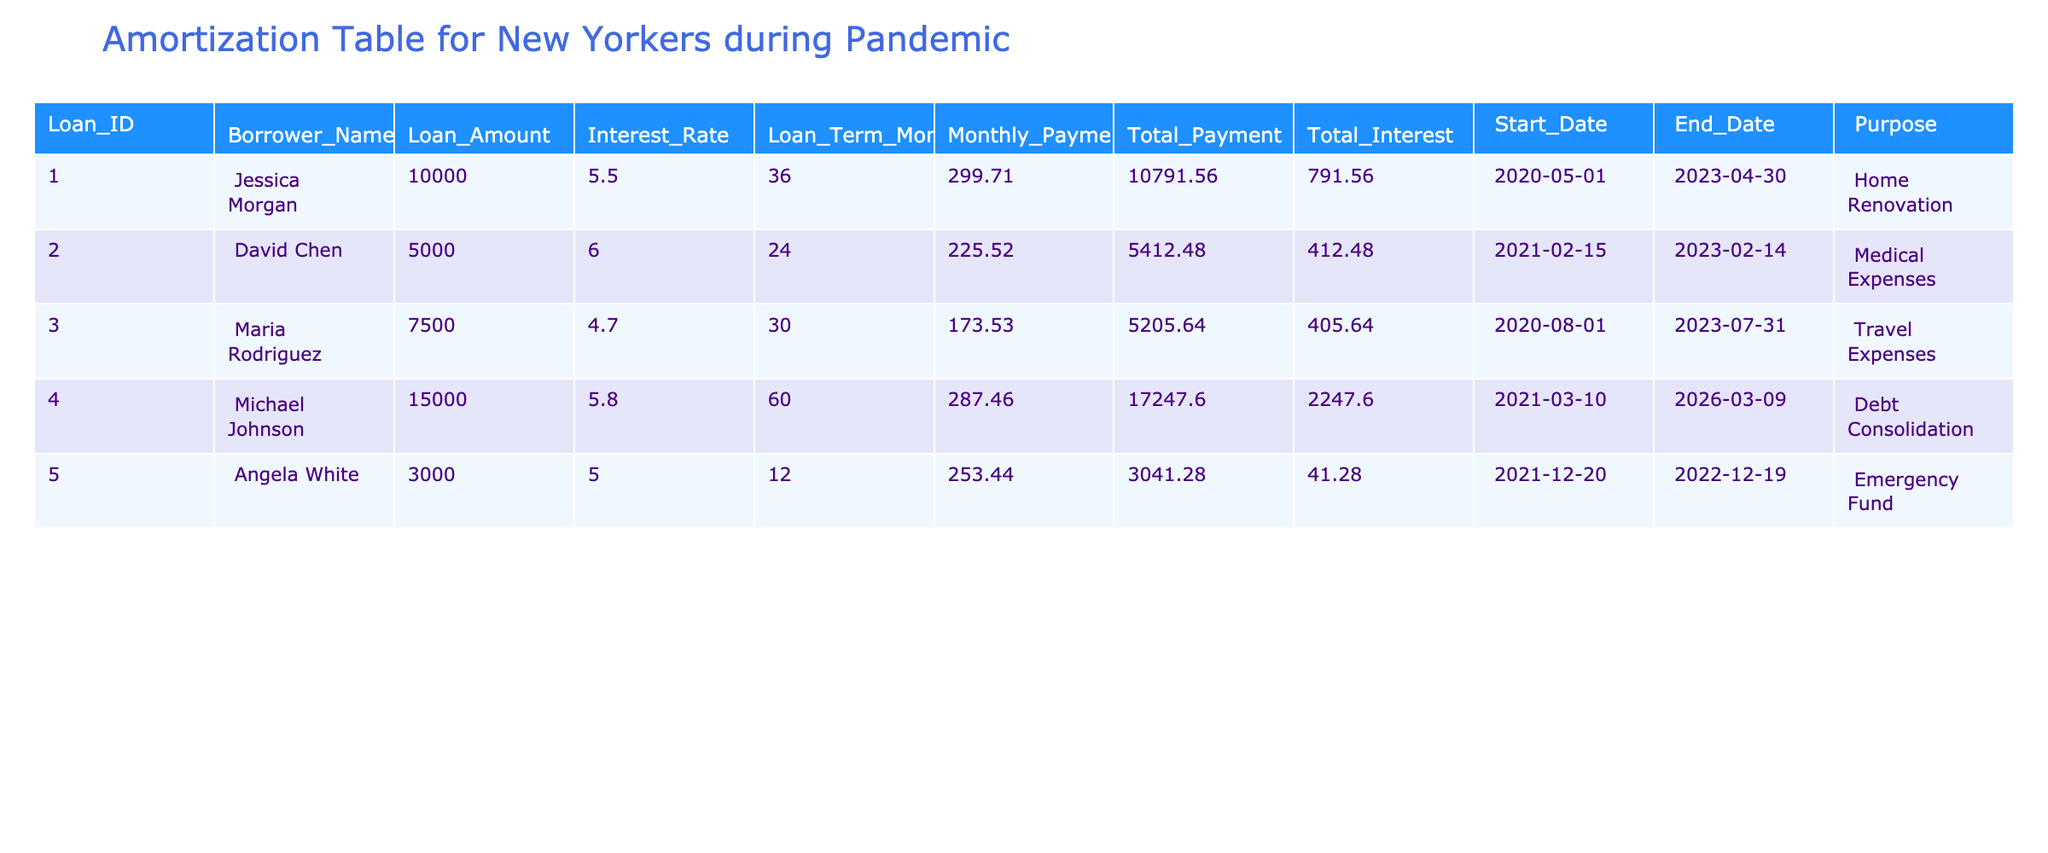What is the total loan amount of all borrowers listed in the table? To find the total loan amount, we add up the Loan Amount column: 10000 + 5000 + 7500 + 15000 + 3000 = 40500.
Answer: 40500 How much total interest did David Chen pay over the course of his loan? The Total Interest column shows 412.48 for David Chen.
Answer: 412.48 Which loan has the highest monthly payment, and what is that amount? Looking at the Monthly Payment column, Michael Johnson has the highest payment of 287.46.
Answer: 287.46 Is there a loan taken out for travel expenses? Yes, Maria Rodriguez took out a loan for travel expenses as listed in the Purpose column.
Answer: Yes What is the average interest rate of all the loans in the table? To find the average interest rate, we sum the Interest Rates (5.5 + 6 + 4.7 + 5.8 + 5.0 = 27) and divide by the number of loans (5): 27 / 5 = 5.4.
Answer: 5.4 Which borrower has the longest loan term, and how many months is it? The longest loan term is for Michael Johnson with a term of 60 months, as we see in the Loan Term Months column.
Answer: 60 months How much did Angela White pay in total for her emergency fund loan? According to the Total Payment column, Angela White's Total Payment is 3041.28.
Answer: 3041.28 Did Jessica Morgan take her loan out for medical expenses? No, Jessica Morgan's loan purpose was for home renovation, not medical expenses.
Answer: No How much more did Michael Johnson pay in interest compared to Maria Rodriguez? Michael Johnson paid 2247.60 in interest while Maria Rodriguez paid 405.64. Thus, the difference is 2247.60 - 405.64 = 1841.96.
Answer: 1841.96 